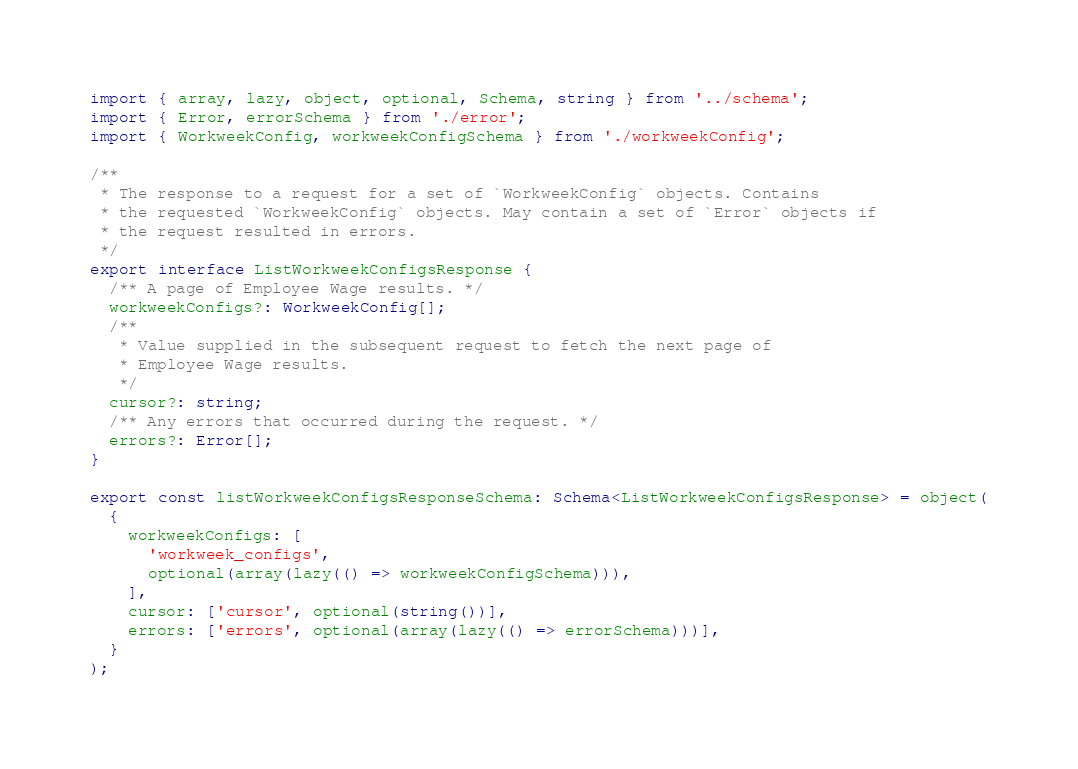<code> <loc_0><loc_0><loc_500><loc_500><_TypeScript_>import { array, lazy, object, optional, Schema, string } from '../schema';
import { Error, errorSchema } from './error';
import { WorkweekConfig, workweekConfigSchema } from './workweekConfig';

/**
 * The response to a request for a set of `WorkweekConfig` objects. Contains
 * the requested `WorkweekConfig` objects. May contain a set of `Error` objects if
 * the request resulted in errors.
 */
export interface ListWorkweekConfigsResponse {
  /** A page of Employee Wage results. */
  workweekConfigs?: WorkweekConfig[];
  /**
   * Value supplied in the subsequent request to fetch the next page of
   * Employee Wage results.
   */
  cursor?: string;
  /** Any errors that occurred during the request. */
  errors?: Error[];
}

export const listWorkweekConfigsResponseSchema: Schema<ListWorkweekConfigsResponse> = object(
  {
    workweekConfigs: [
      'workweek_configs',
      optional(array(lazy(() => workweekConfigSchema))),
    ],
    cursor: ['cursor', optional(string())],
    errors: ['errors', optional(array(lazy(() => errorSchema)))],
  }
);
</code> 